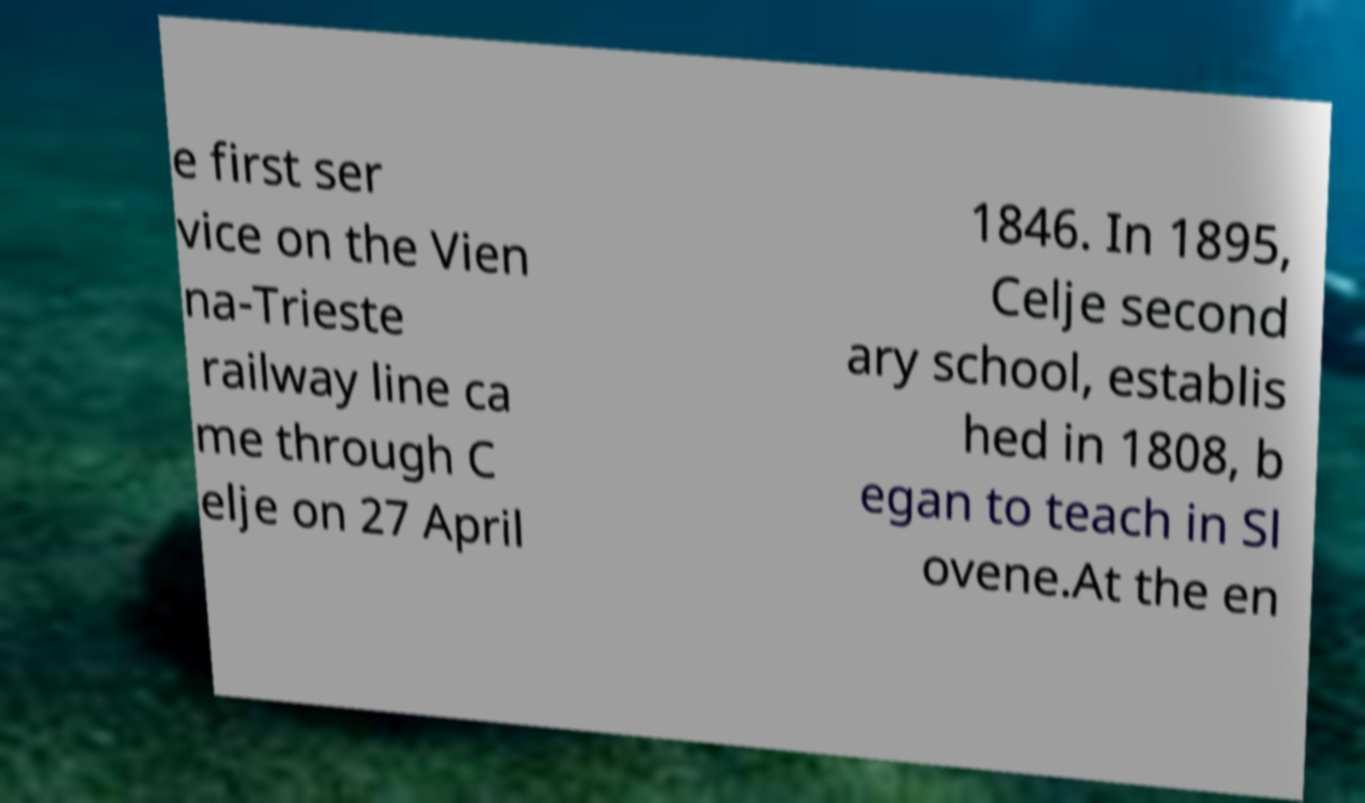There's text embedded in this image that I need extracted. Can you transcribe it verbatim? e first ser vice on the Vien na-Trieste railway line ca me through C elje on 27 April 1846. In 1895, Celje second ary school, establis hed in 1808, b egan to teach in Sl ovene.At the en 